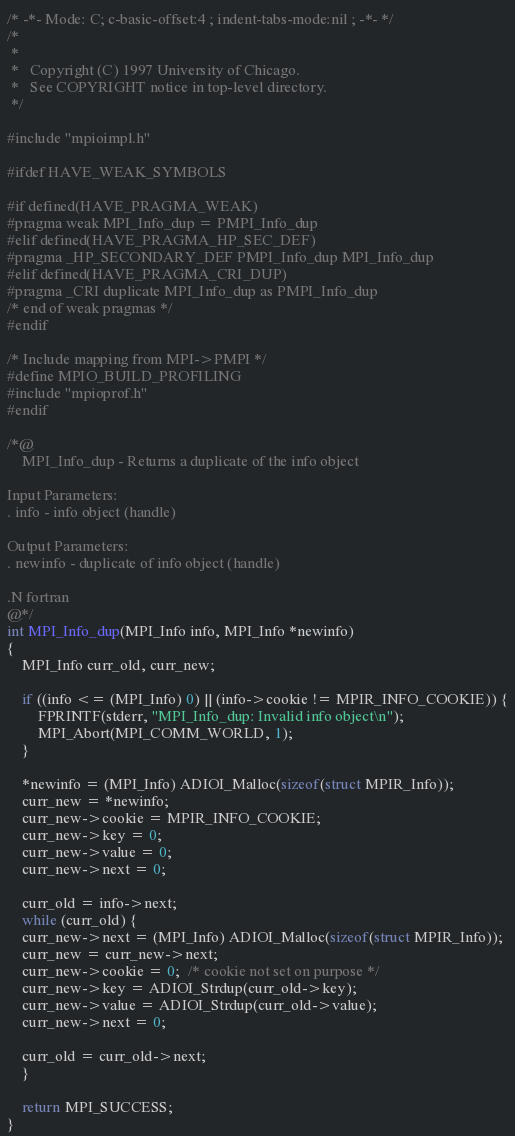<code> <loc_0><loc_0><loc_500><loc_500><_C_>/* -*- Mode: C; c-basic-offset:4 ; indent-tabs-mode:nil ; -*- */
/*
 *
 *   Copyright (C) 1997 University of Chicago.
 *   See COPYRIGHT notice in top-level directory.
 */

#include "mpioimpl.h"

#ifdef HAVE_WEAK_SYMBOLS

#if defined(HAVE_PRAGMA_WEAK)
#pragma weak MPI_Info_dup = PMPI_Info_dup
#elif defined(HAVE_PRAGMA_HP_SEC_DEF)
#pragma _HP_SECONDARY_DEF PMPI_Info_dup MPI_Info_dup
#elif defined(HAVE_PRAGMA_CRI_DUP)
#pragma _CRI duplicate MPI_Info_dup as PMPI_Info_dup
/* end of weak pragmas */
#endif

/* Include mapping from MPI->PMPI */
#define MPIO_BUILD_PROFILING
#include "mpioprof.h"
#endif

/*@
    MPI_Info_dup - Returns a duplicate of the info object

Input Parameters:
. info - info object (handle)

Output Parameters:
. newinfo - duplicate of info object (handle)

.N fortran
@*/
int MPI_Info_dup(MPI_Info info, MPI_Info *newinfo)
{
    MPI_Info curr_old, curr_new;

    if ((info <= (MPI_Info) 0) || (info->cookie != MPIR_INFO_COOKIE)) {
        FPRINTF(stderr, "MPI_Info_dup: Invalid info object\n");
        MPI_Abort(MPI_COMM_WORLD, 1);
    }

    *newinfo = (MPI_Info) ADIOI_Malloc(sizeof(struct MPIR_Info));
    curr_new = *newinfo;
    curr_new->cookie = MPIR_INFO_COOKIE;
    curr_new->key = 0;
    curr_new->value = 0;
    curr_new->next = 0;

    curr_old = info->next;
    while (curr_old) {
	curr_new->next = (MPI_Info) ADIOI_Malloc(sizeof(struct MPIR_Info));
	curr_new = curr_new->next;
	curr_new->cookie = 0;  /* cookie not set on purpose */
	curr_new->key = ADIOI_Strdup(curr_old->key);
	curr_new->value = ADIOI_Strdup(curr_old->value);
	curr_new->next = 0;

	curr_old = curr_old->next;
    }

    return MPI_SUCCESS;
}
</code> 